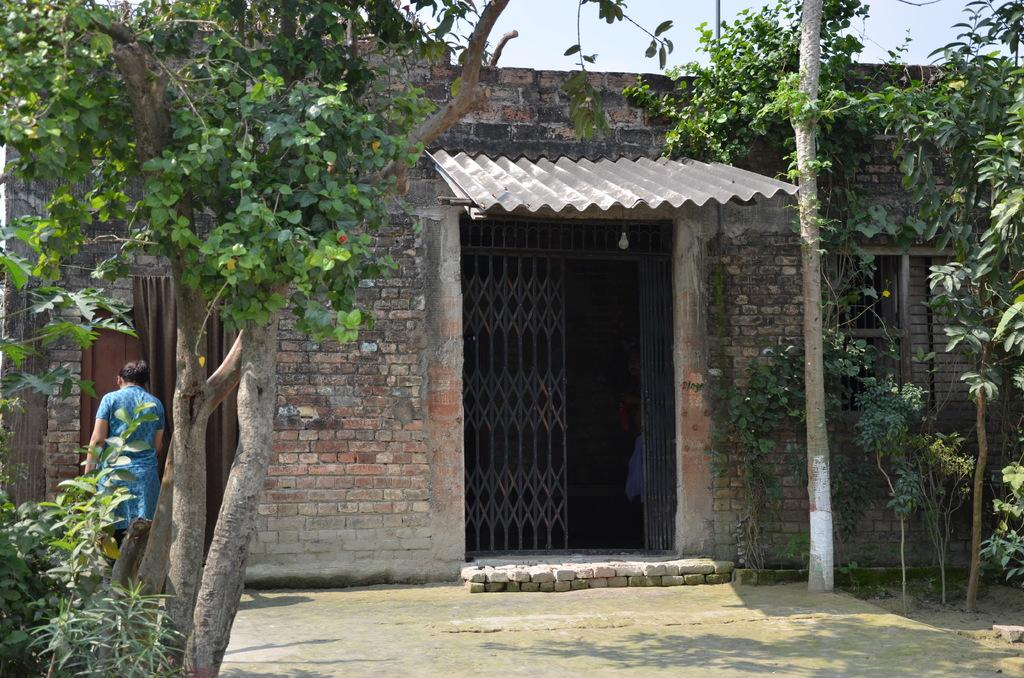What type of structure is present in the image? There is a house in the image. What features can be seen on the house? The house has a gate and windows. Who or what is in front of the house? There is a person in front of the house. What type of vegetation is present in the image? There are trees in the image. What other object can be seen in the image? There is a pole in the image. What is visible in the background of the image? The sky is visible in the image. Where is the sofa located in the image? There is no sofa present in the image. How many birds are in the flock near the house? There is no flock of birds present in the image. 